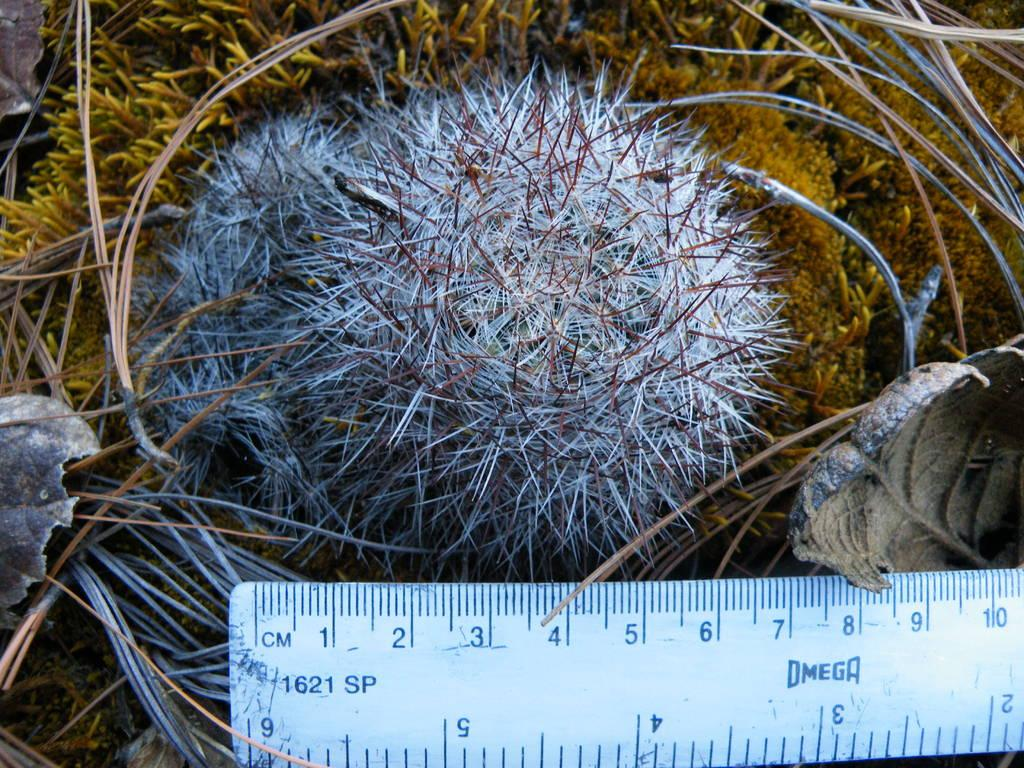<image>
Relay a brief, clear account of the picture shown. A porcupine is being measured with an Omega ruler 